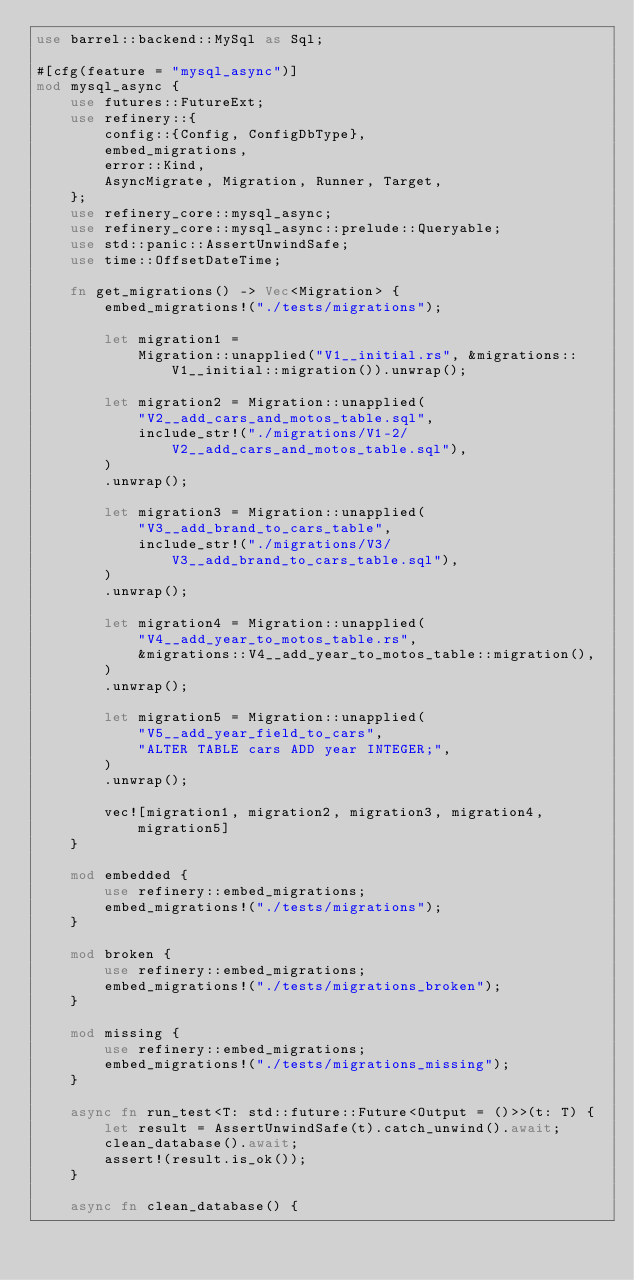Convert code to text. <code><loc_0><loc_0><loc_500><loc_500><_Rust_>use barrel::backend::MySql as Sql;

#[cfg(feature = "mysql_async")]
mod mysql_async {
    use futures::FutureExt;
    use refinery::{
        config::{Config, ConfigDbType},
        embed_migrations,
        error::Kind,
        AsyncMigrate, Migration, Runner, Target,
    };
    use refinery_core::mysql_async;
    use refinery_core::mysql_async::prelude::Queryable;
    use std::panic::AssertUnwindSafe;
    use time::OffsetDateTime;

    fn get_migrations() -> Vec<Migration> {
        embed_migrations!("./tests/migrations");

        let migration1 =
            Migration::unapplied("V1__initial.rs", &migrations::V1__initial::migration()).unwrap();

        let migration2 = Migration::unapplied(
            "V2__add_cars_and_motos_table.sql",
            include_str!("./migrations/V1-2/V2__add_cars_and_motos_table.sql"),
        )
        .unwrap();

        let migration3 = Migration::unapplied(
            "V3__add_brand_to_cars_table",
            include_str!("./migrations/V3/V3__add_brand_to_cars_table.sql"),
        )
        .unwrap();

        let migration4 = Migration::unapplied(
            "V4__add_year_to_motos_table.rs",
            &migrations::V4__add_year_to_motos_table::migration(),
        )
        .unwrap();

        let migration5 = Migration::unapplied(
            "V5__add_year_field_to_cars",
            "ALTER TABLE cars ADD year INTEGER;",
        )
        .unwrap();

        vec![migration1, migration2, migration3, migration4, migration5]
    }

    mod embedded {
        use refinery::embed_migrations;
        embed_migrations!("./tests/migrations");
    }

    mod broken {
        use refinery::embed_migrations;
        embed_migrations!("./tests/migrations_broken");
    }

    mod missing {
        use refinery::embed_migrations;
        embed_migrations!("./tests/migrations_missing");
    }

    async fn run_test<T: std::future::Future<Output = ()>>(t: T) {
        let result = AssertUnwindSafe(t).catch_unwind().await;
        clean_database().await;
        assert!(result.is_ok());
    }

    async fn clean_database() {</code> 